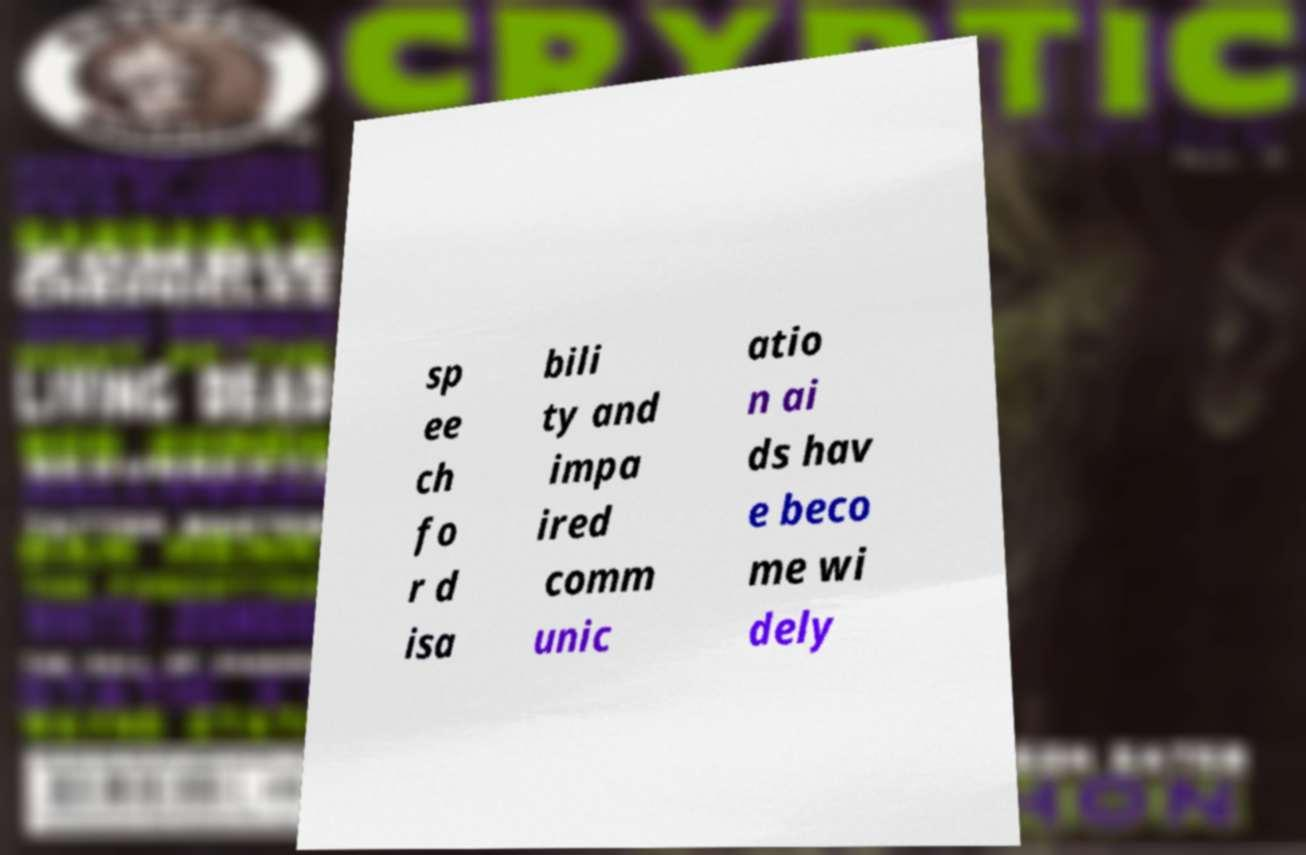There's text embedded in this image that I need extracted. Can you transcribe it verbatim? sp ee ch fo r d isa bili ty and impa ired comm unic atio n ai ds hav e beco me wi dely 